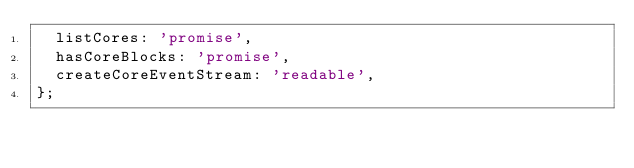Convert code to text. <code><loc_0><loc_0><loc_500><loc_500><_JavaScript_>  listCores: 'promise',
  hasCoreBlocks: 'promise',
  createCoreEventStream: 'readable',
};
</code> 